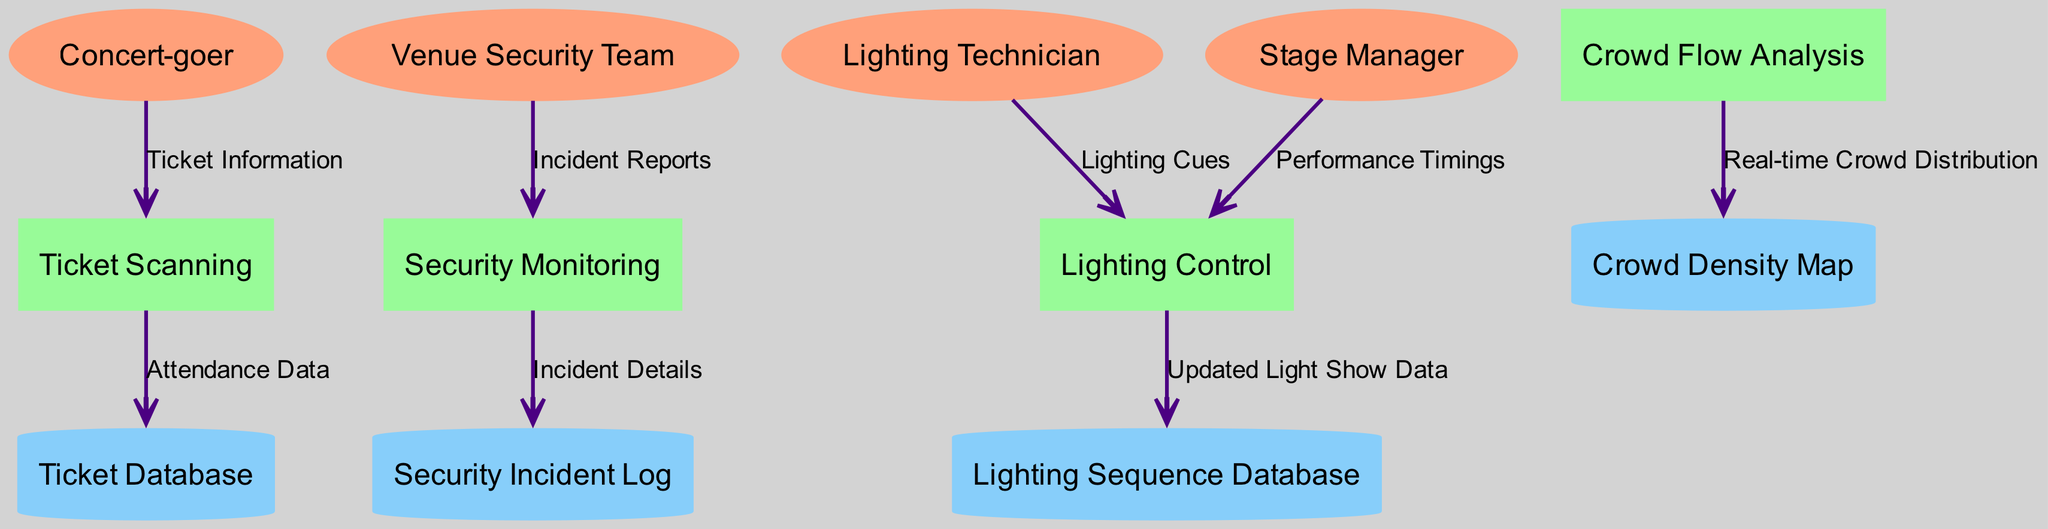What entity does the "Incident Reports" flow from? The "Incident Reports" data flow originates from the "Venue Security Team," indicating that they are responsible for providing information regarding security incidents.
Answer: Venue Security Team How many external entities are there in the diagram? By counting the listed external entities, there are four entities identified: Concert-goer, Venue Security Team, Lighting Technician, and Stage Manager.
Answer: Four What is the relationship between "Security Monitoring" and "Security Incident Log"? "Security Monitoring" sends "Incident Details" to the "Security Incident Log," indicating that the monitoring process documents detailed incidents that occur during the event.
Answer: Incident Details How many data flows are in the diagram? The diagram presents a total of seven distinct data flows connecting the entities, processes, and data stores depicted.
Answer: Seven What process receives "Lighting Cues"? The "Lighting Control" process takes in the "Lighting Cues" from the "Lighting Technician," indicating their role in managing the lighting during the concert.
Answer: Lighting Control What data store is related to performance timings? The "Lighting Control" process receives "Performance Timings" from the "Stage Manager," suggesting that the respective stored data is related to adjusting lighting according to scheduled performance events, but it doesn't link directly to a specific data store.
Answer: None What does "Crowd Flow Analysis" update? "Crowd Flow Analysis" updates the "Crowd Density Map" with real-time data on crowd distribution, showcasing the dynamics of venue population during the concert.
Answer: Crowd Density Map How does the ticket scanning process contribute to overall attendance data? The "Ticket Scanning" process forwards "Attendance Data" to the "Ticket Database," effectively logging the attendees for future reference and management related to concert turnout.
Answer: Ticket Database 